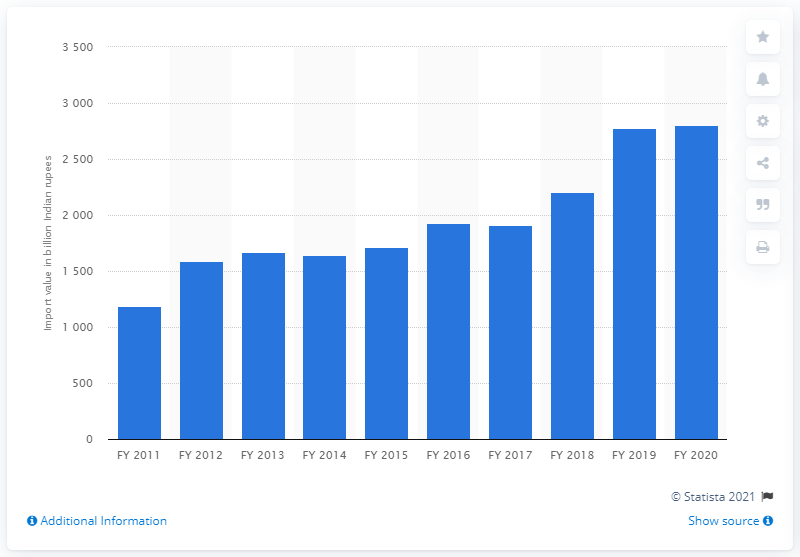Identify some key points in this picture. In the fiscal year 2020, India imported machinery worth 2802.08 Indian rupees. 